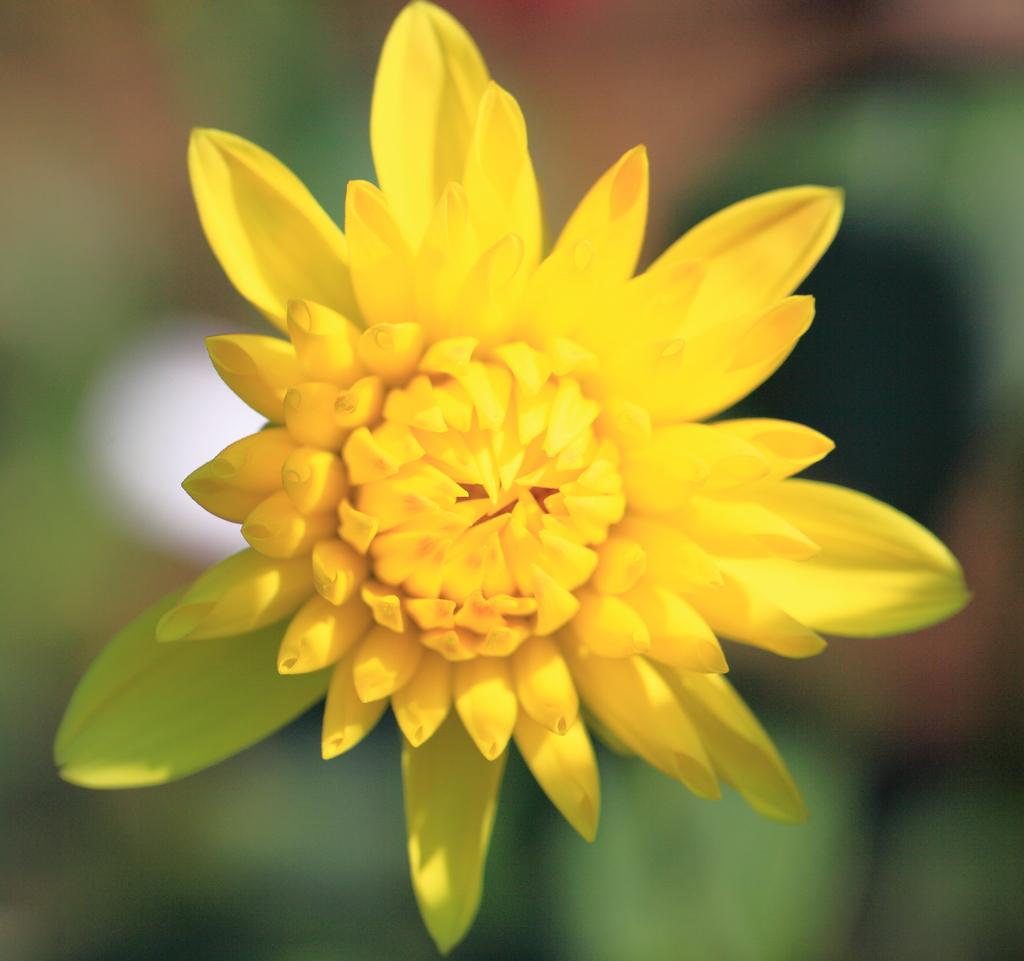What is the main subject of the image? There is a flower in the image. What color is the flower? The flower is yellow in color. Can you describe the background of the image? The background of the image is blurry. What type of sheet is covering the oven in the image? There is no sheet or oven present in the image; it only features a yellow flower with a blurry background. 